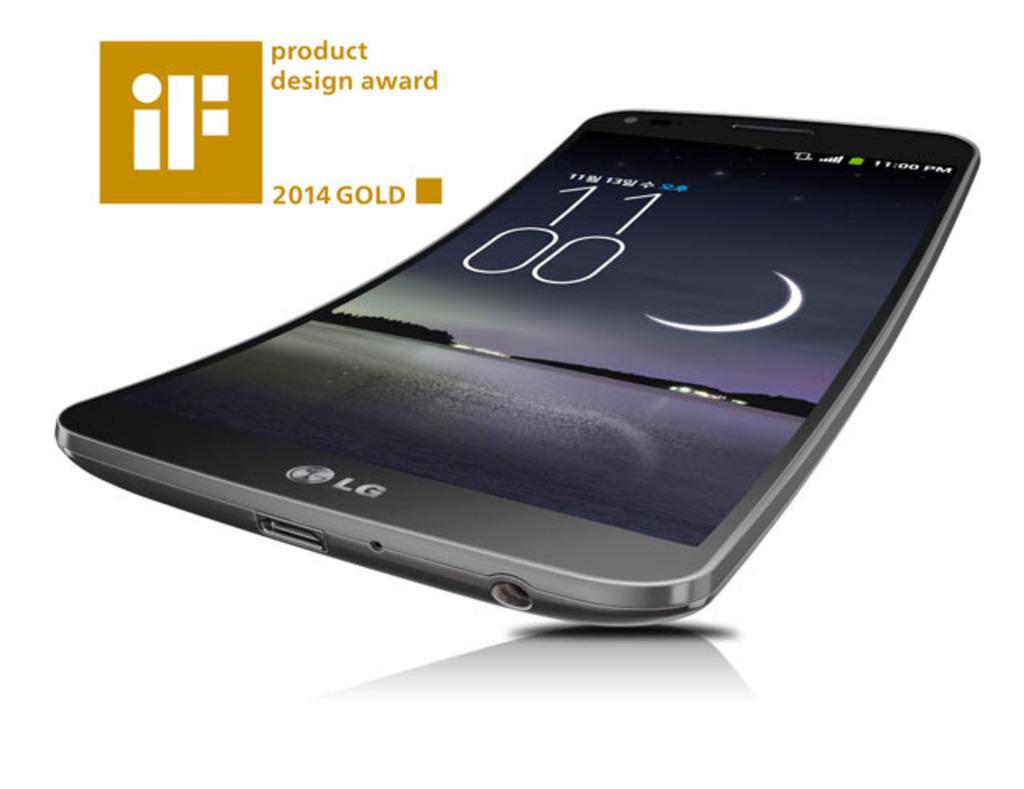What year did they win the gold?
Your response must be concise. 2014. What brand of phone?
Your response must be concise. Lg. 